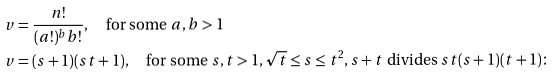<formula> <loc_0><loc_0><loc_500><loc_500>v & = \frac { n ! } { ( a ! ) ^ { b } b ! } , \quad \text {for some } a , b > 1 \\ v & = ( s + 1 ) ( s t + 1 ) , \quad \text {for some } s , t > 1 , \sqrt { t } \leq s \leq t ^ { 2 } , s + t \text { divides } s t ( s + 1 ) ( t + 1 ) \colon</formula> 